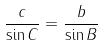Convert formula to latex. <formula><loc_0><loc_0><loc_500><loc_500>\frac { c } { \sin C } = \frac { b } { \sin B }</formula> 